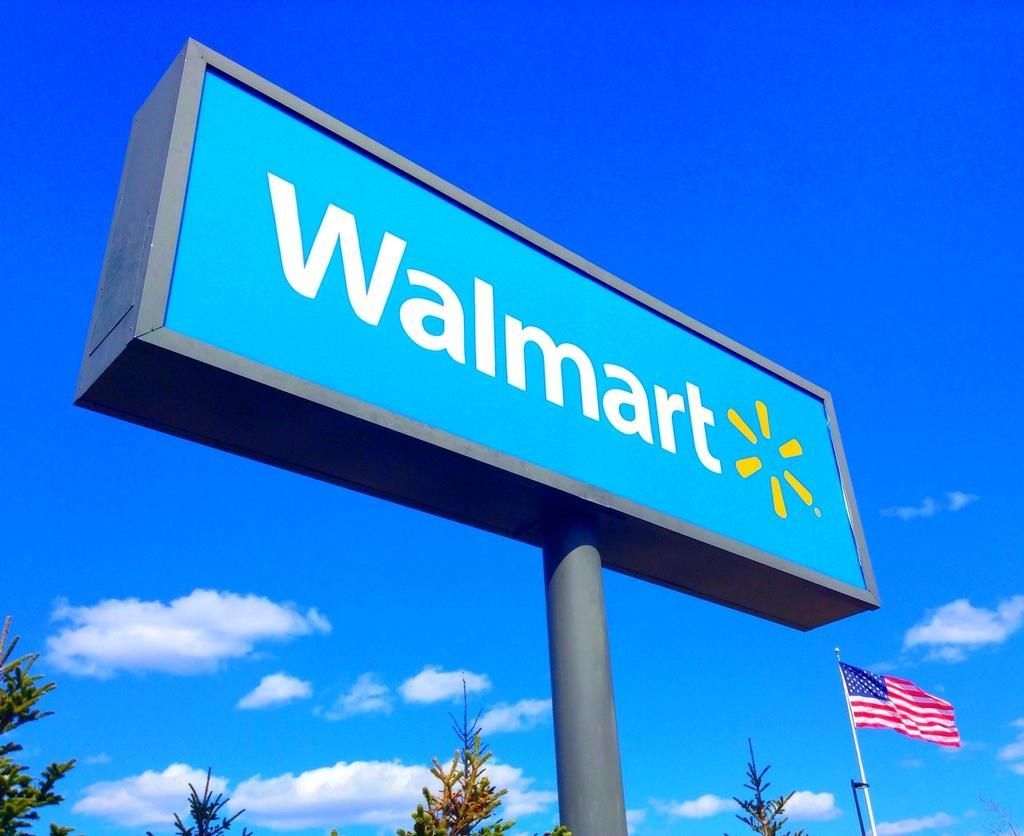Could you give a brief overview of what you see in this image? In this image we can see a banner board. At the bottom of the image, we can see greenery, poles and a flag. In the background, we can see the sky with clouds. 